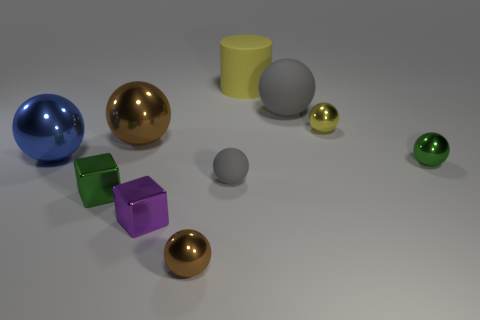Subtract 1 balls. How many balls are left? 6 Subtract all yellow spheres. How many spheres are left? 6 Subtract all small yellow spheres. How many spheres are left? 6 Subtract all yellow spheres. Subtract all cyan cylinders. How many spheres are left? 6 Subtract all spheres. How many objects are left? 3 Subtract all green metal things. Subtract all small brown metal balls. How many objects are left? 7 Add 4 tiny purple objects. How many tiny purple objects are left? 5 Add 8 tiny green metal balls. How many tiny green metal balls exist? 9 Subtract 1 purple blocks. How many objects are left? 9 